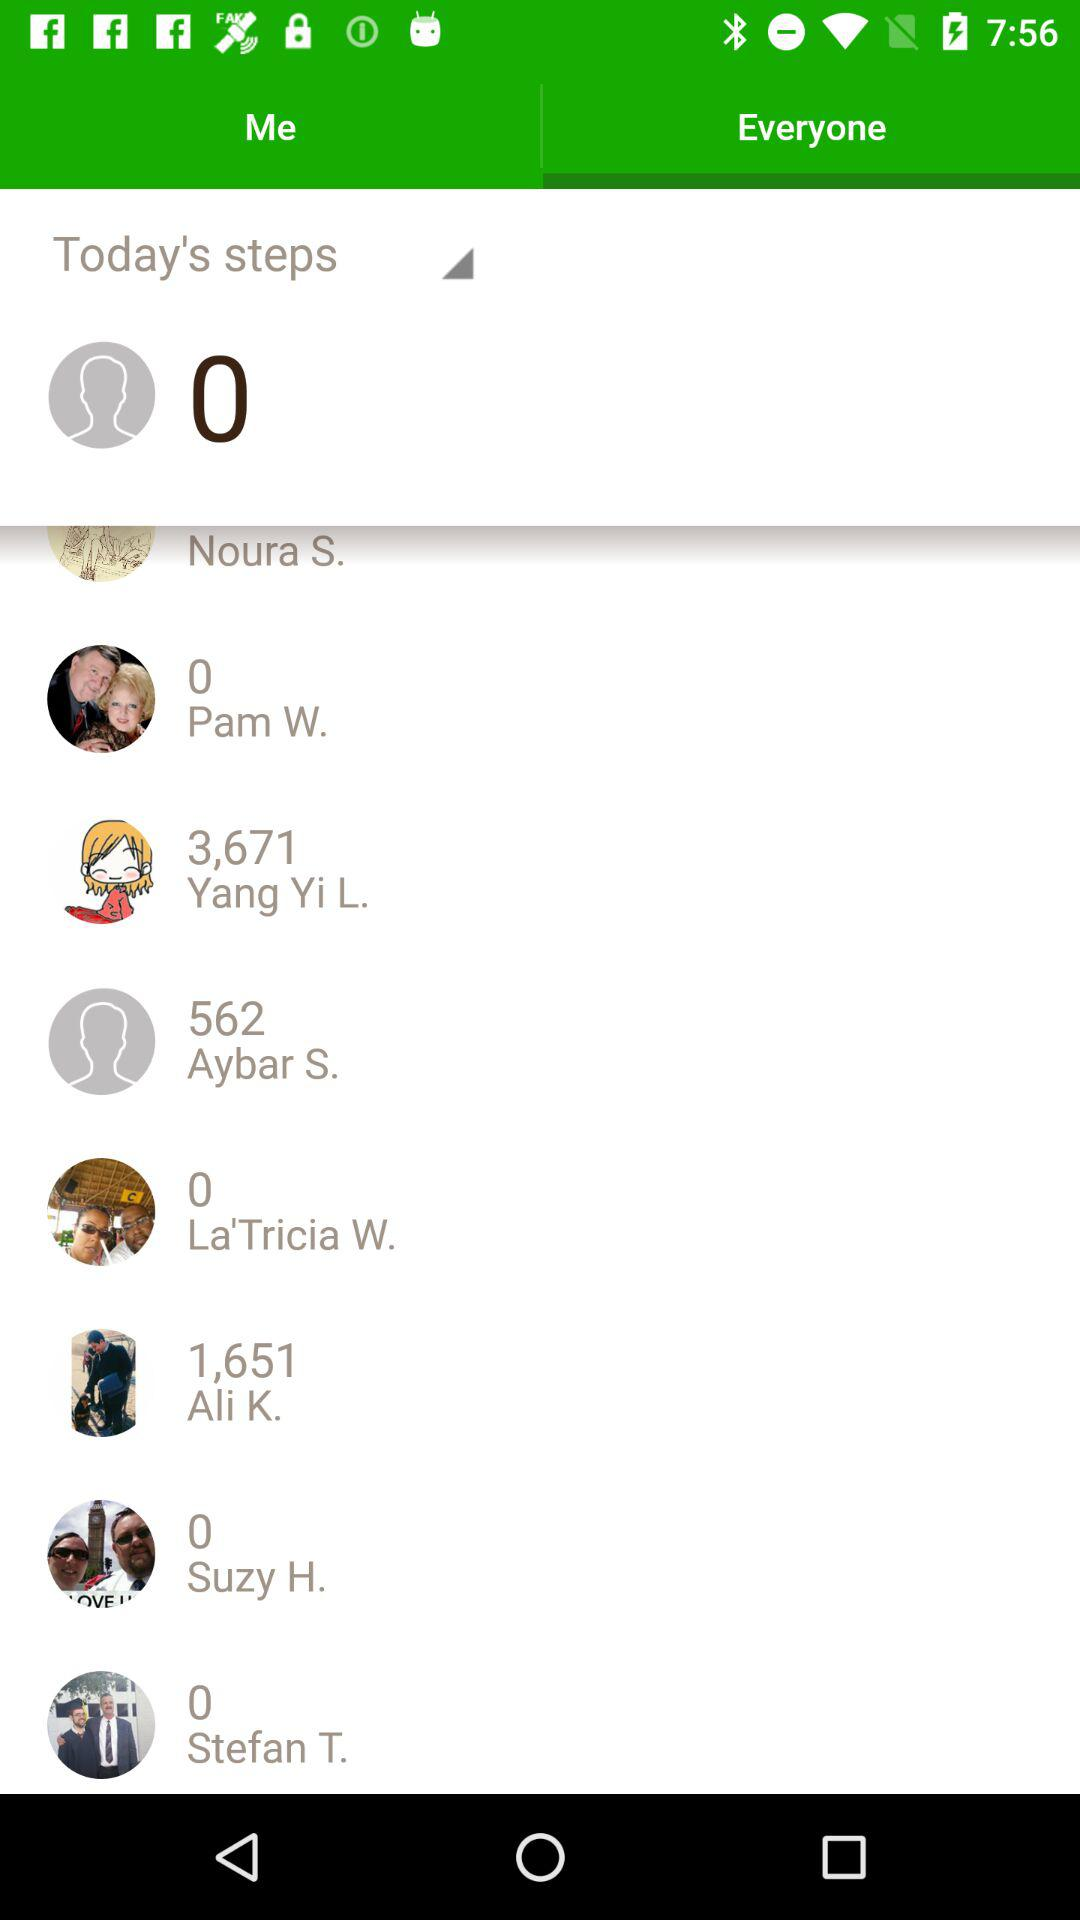Which tab is selected? The selected tab is "Everyone". 